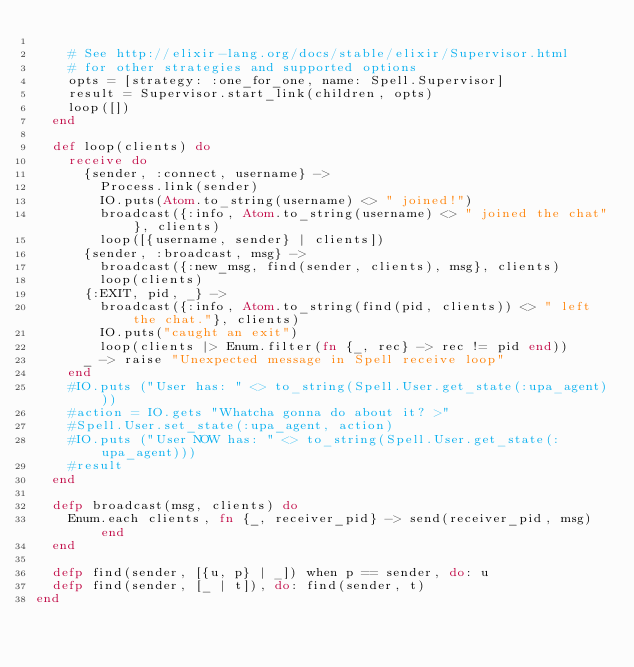Convert code to text. <code><loc_0><loc_0><loc_500><loc_500><_Elixir_>
    # See http://elixir-lang.org/docs/stable/elixir/Supervisor.html
    # for other strategies and supported options
    opts = [strategy: :one_for_one, name: Spell.Supervisor]
    result = Supervisor.start_link(children, opts)
    loop([])
  end

  def loop(clients) do
    receive do
      {sender, :connect, username} ->
        Process.link(sender)
        IO.puts(Atom.to_string(username) <> " joined!")
        broadcast({:info, Atom.to_string(username) <> " joined the chat"}, clients)
        loop([{username, sender} | clients])
      {sender, :broadcast, msg} ->
        broadcast({:new_msg, find(sender, clients), msg}, clients)
        loop(clients)
      {:EXIT, pid, _} ->
        broadcast({:info, Atom.to_string(find(pid, clients)) <> " left the chat."}, clients)
        IO.puts("caught an exit")
        loop(clients |> Enum.filter(fn {_, rec} -> rec != pid end))
      _ -> raise "Unexpected message in Spell receive loop"
    end
    #IO.puts ("User has: " <> to_string(Spell.User.get_state(:upa_agent)))
    #action = IO.gets "Whatcha gonna do about it? >"
    #Spell.User.set_state(:upa_agent, action)
    #IO.puts ("User NOW has: " <> to_string(Spell.User.get_state(:upa_agent)))
    #result
  end

  defp broadcast(msg, clients) do
    Enum.each clients, fn {_, receiver_pid} -> send(receiver_pid, msg) end
  end

  defp find(sender, [{u, p} | _]) when p == sender, do: u
  defp find(sender, [_ | t]), do: find(sender, t)
end
</code> 